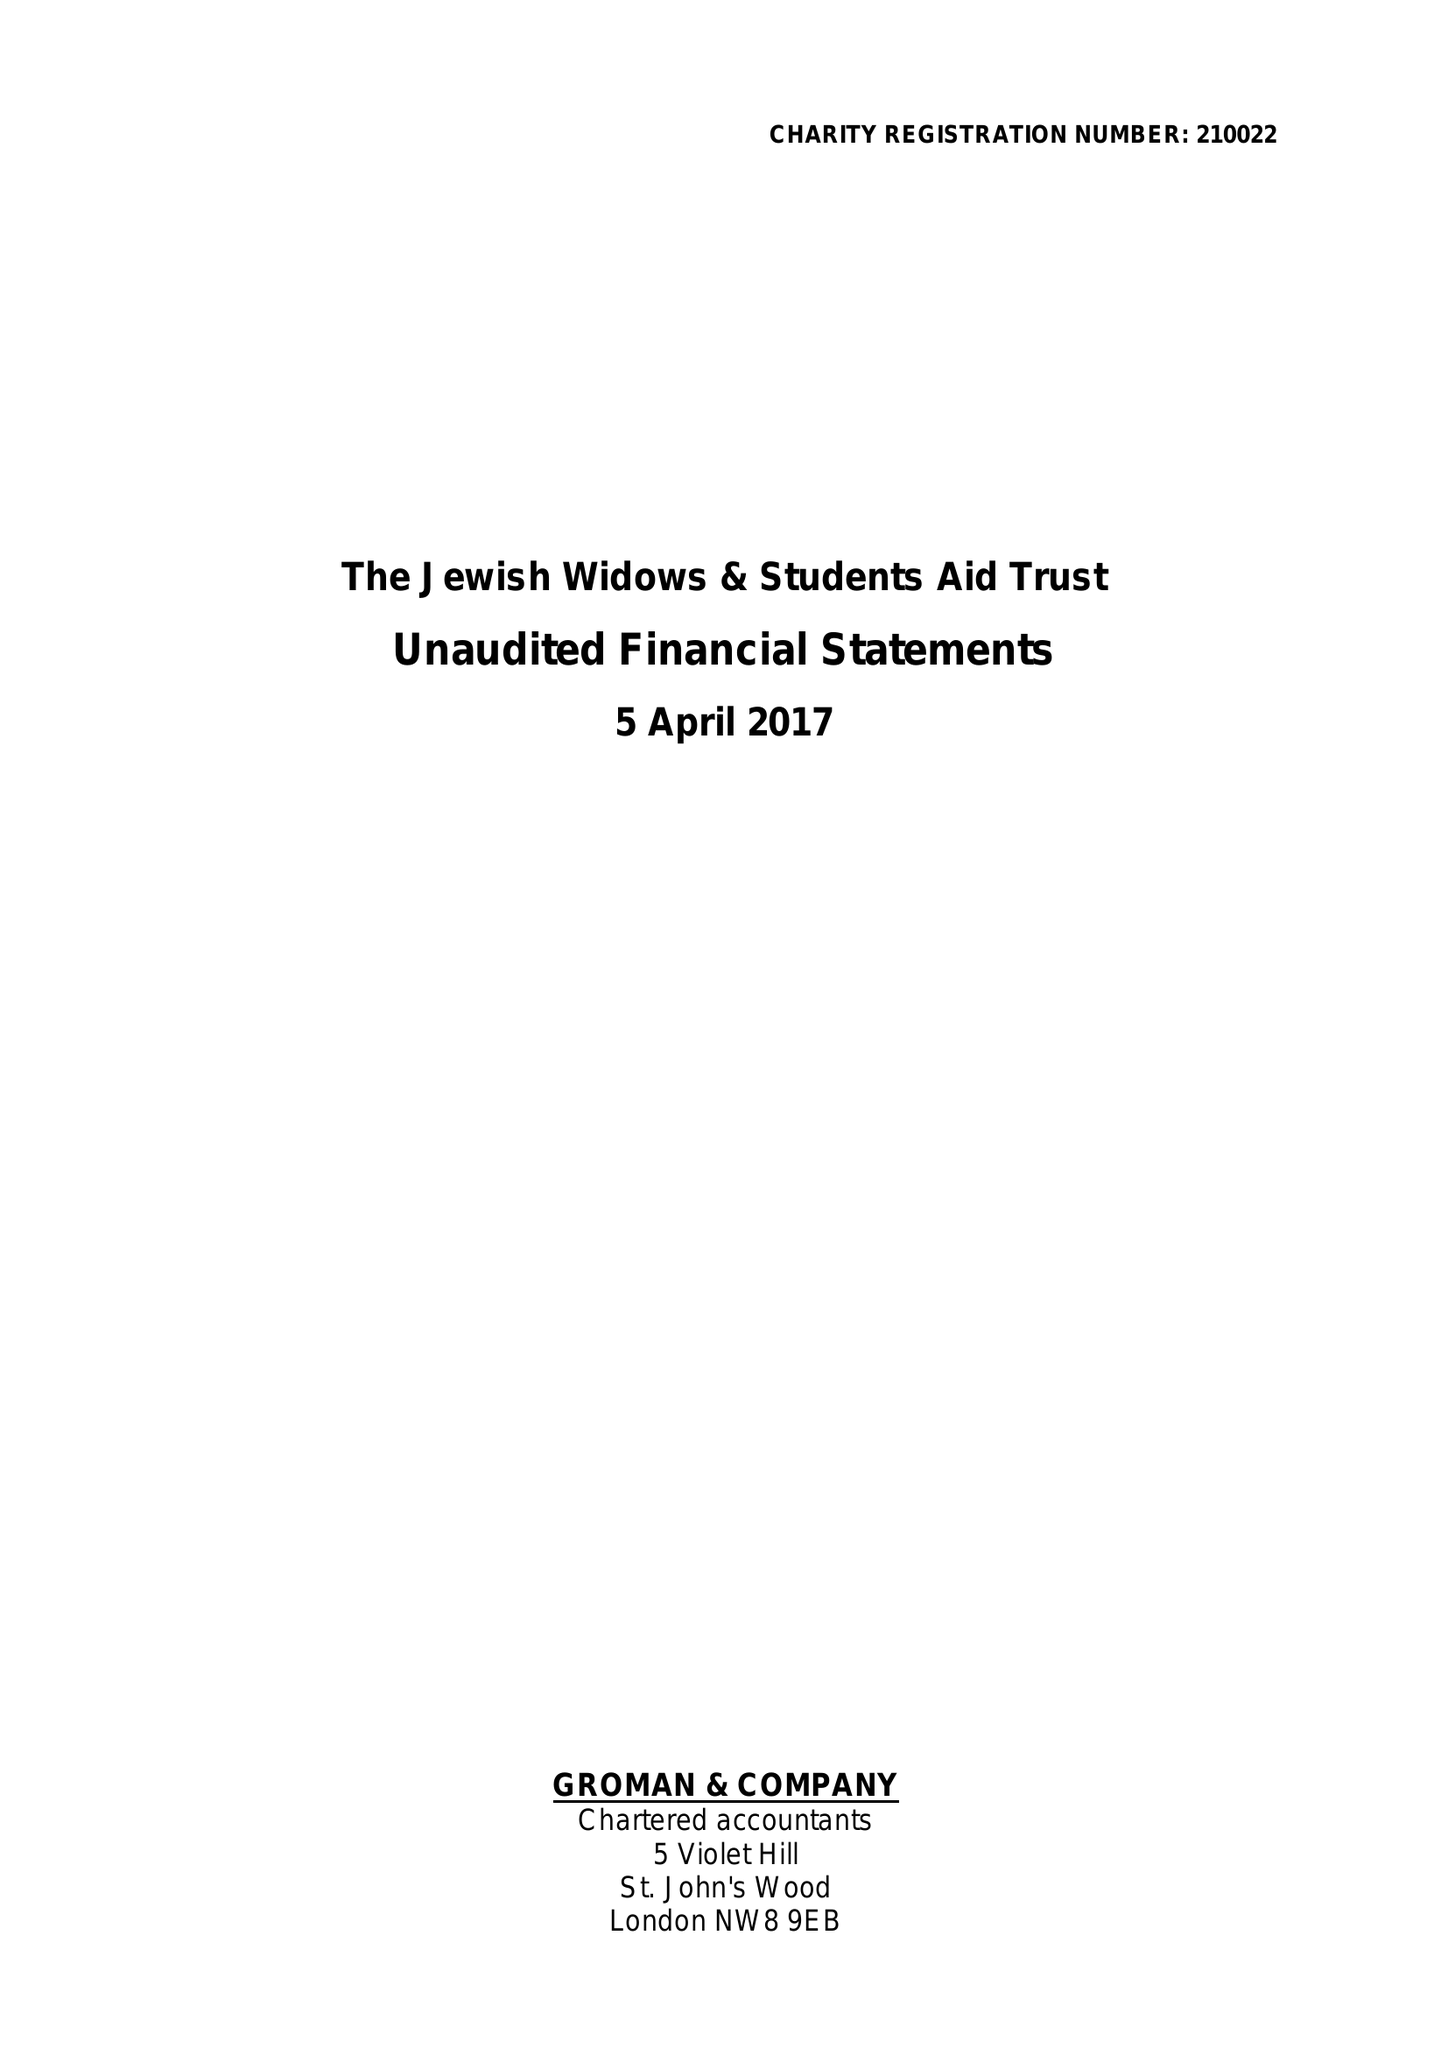What is the value for the charity_number?
Answer the question using a single word or phrase. 210022 